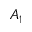<formula> <loc_0><loc_0><loc_500><loc_500>A _ { 1 }</formula> 